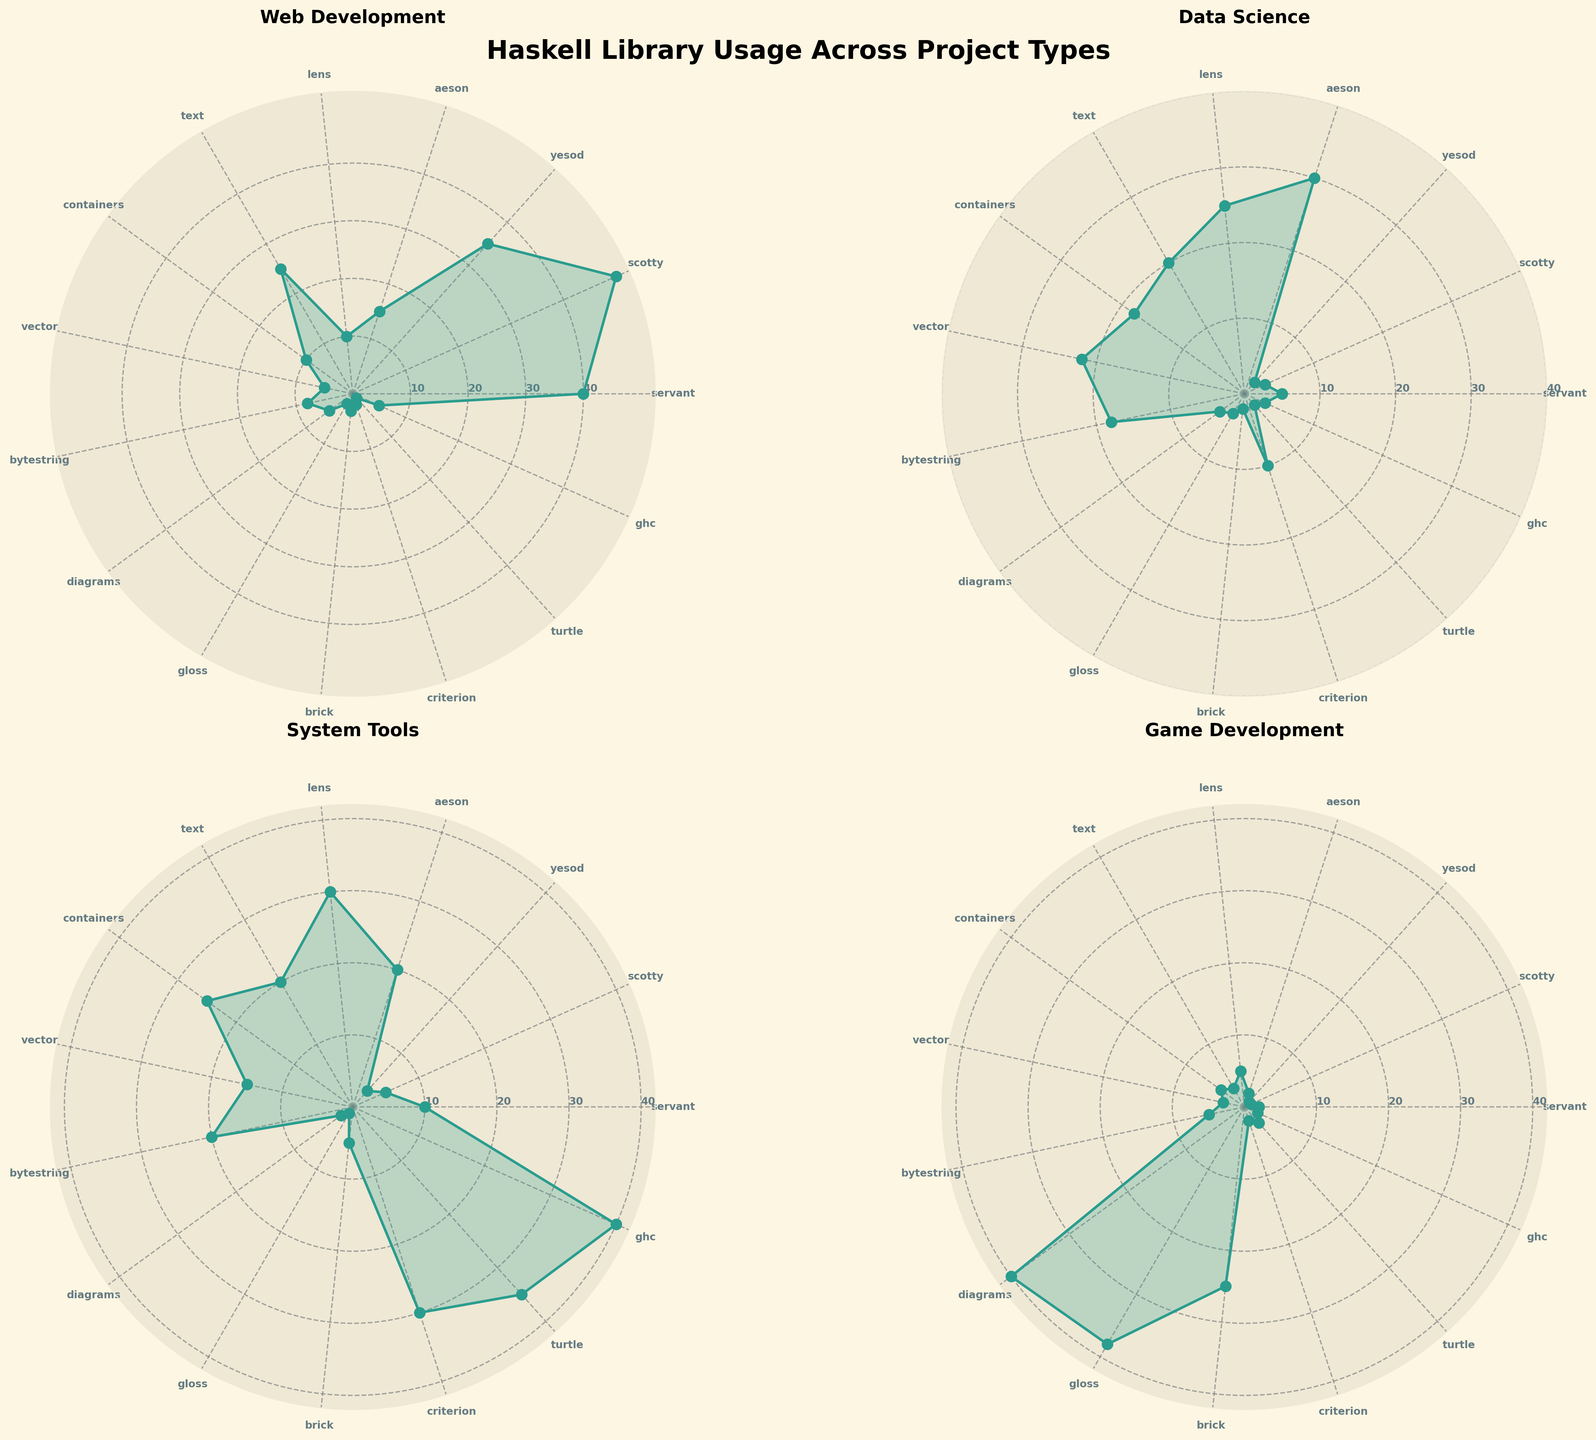What is the title of the main plot? The title of the main plot is positioned at the top center of the figure and reads, "Haskell Library Usage Across Project Types".
Answer: Haskell Library Usage Across Project Types Which project type shows the highest usage of the library `servant`? Look at the subplot for each project type and observe the `servant` data points. The longest line from the center corresponding to `servant` can be found in the "Web Development" subplot.
Answer: Web Development What is the range of the radial ticks? Radial ticks are labels shown along the radius of the circle, marking specific values. Each subplot has radial ticks set at 10, 20, 30, and 40.
Answer: 10, 20, 30, 40 Which library has the highest usage in "Game Development" projects? Check the "Game Development" subplot. The library with the longest radial length is `diagrams`, indicating the highest usage in this type of project.
Answer: diagrams How does the usage of `aeson` compare between "Data Science" and "System Tools"? Compare the radial lengths from the center for `aeson` in both "Data Science" and "System Tools" subplots. `aeson` has longer lengths in "Data Science".
Answer: Higher in Data Science What is the average usage of the library `turtle` across all project types? Add the values for `turtle` in each project type and divide by the total number of project types. (1 + 2 + 35 + 3) / 4 = 41 / 4 = 10.25
Answer: 10.25 Which subplot shows the highest usage value for any library, and what is that value? Look through each subplot to find the highest radial value. The highest usage is `ghc` in the "System Tools" subplot, with a value of 40.
Answer: System Tools, 40 Is the usage of `lens` higher in "System Tools" or "Data Science"? Compare the radial lengths for `lens` within both the "System Tools" and "Data Science" subplots. The lengths and values indicate higher usage in "System Tools".
Answer: System Tools What is the median usage of `criterion` across all project types? List the values of `criterion` in all project types: 2, 10, 30, 2. Arrange them: 2, 2, 10, 30. The median is the average of the two middle values: (2+10)/2 = 6.
Answer: 6 How many subplots are there in the figure? The figure arrangement in rows and columns shows there are 4 subplots, each representing a different project type.
Answer: 4 